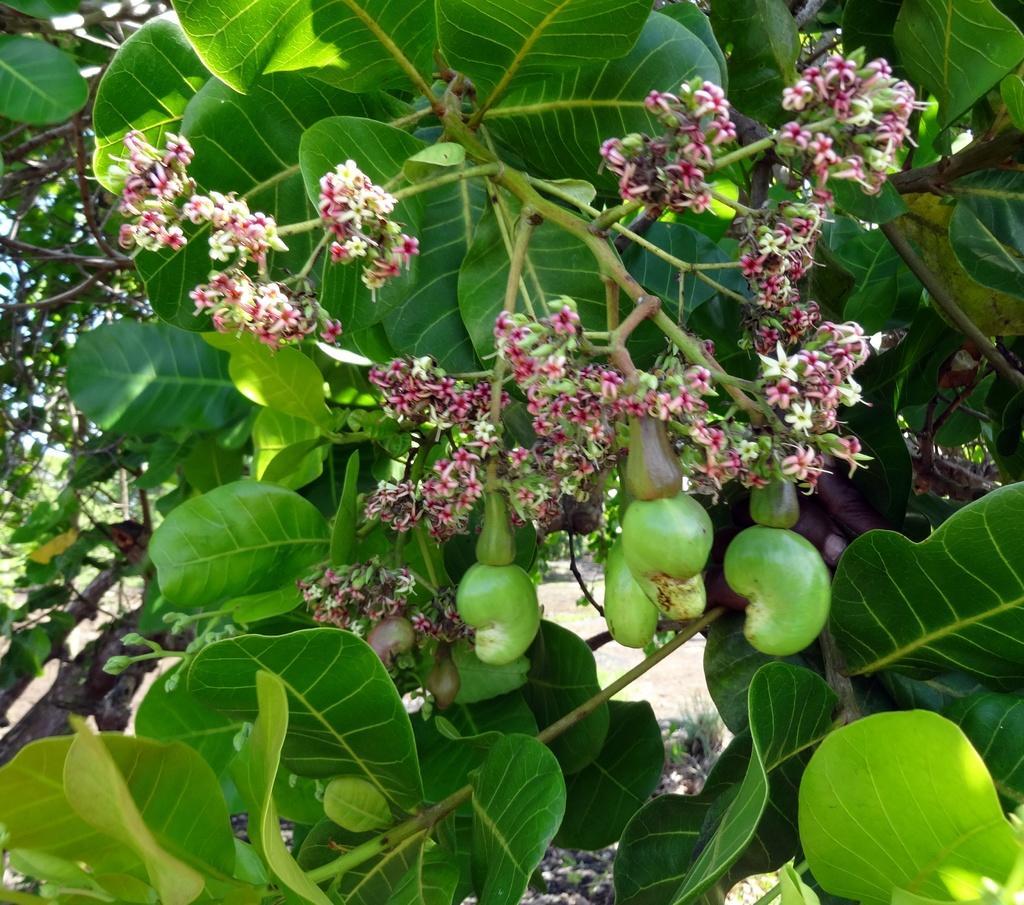In one or two sentences, can you explain what this image depicts? In this image we can see flowers, fruits and leaves of a tree. 